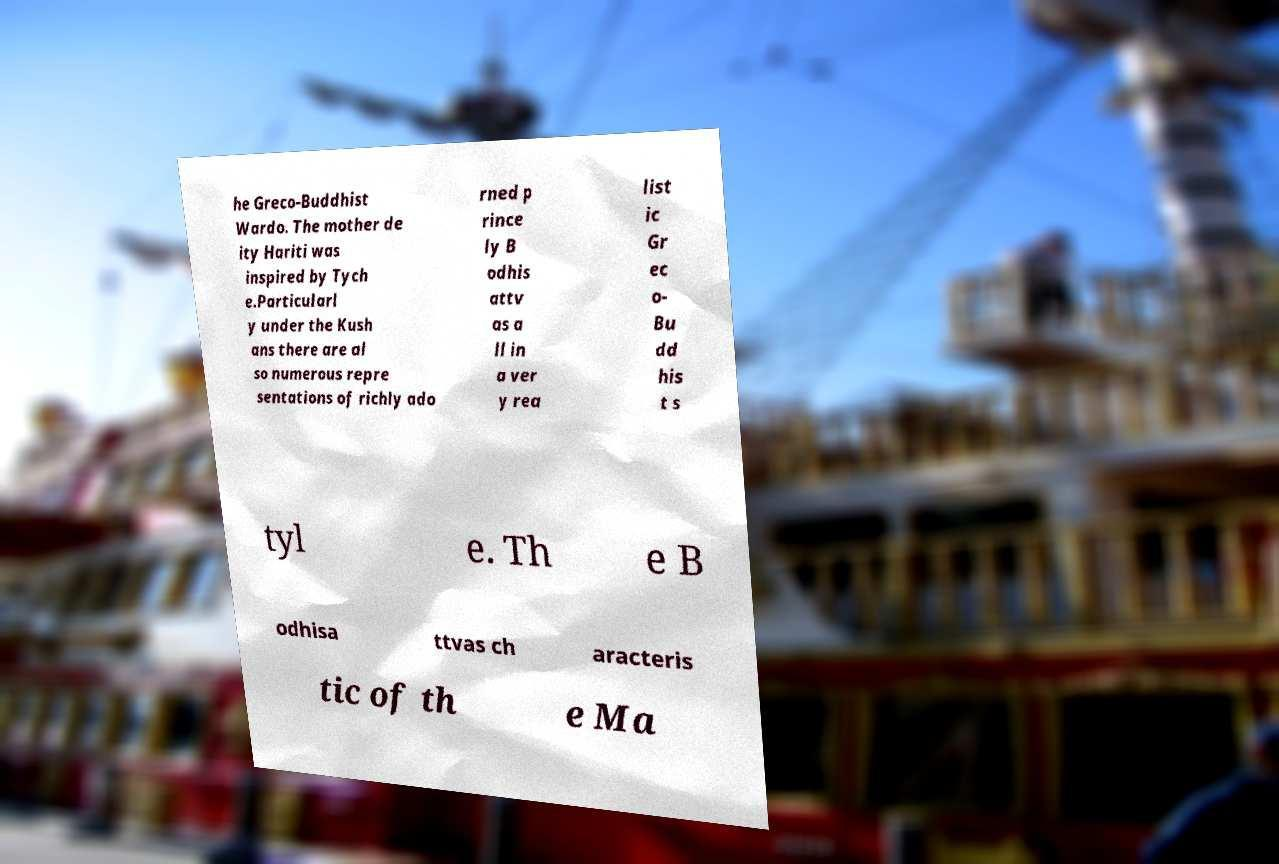Could you assist in decoding the text presented in this image and type it out clearly? he Greco-Buddhist Wardo. The mother de ity Hariti was inspired by Tych e.Particularl y under the Kush ans there are al so numerous repre sentations of richly ado rned p rince ly B odhis attv as a ll in a ver y rea list ic Gr ec o- Bu dd his t s tyl e. Th e B odhisa ttvas ch aracteris tic of th e Ma 